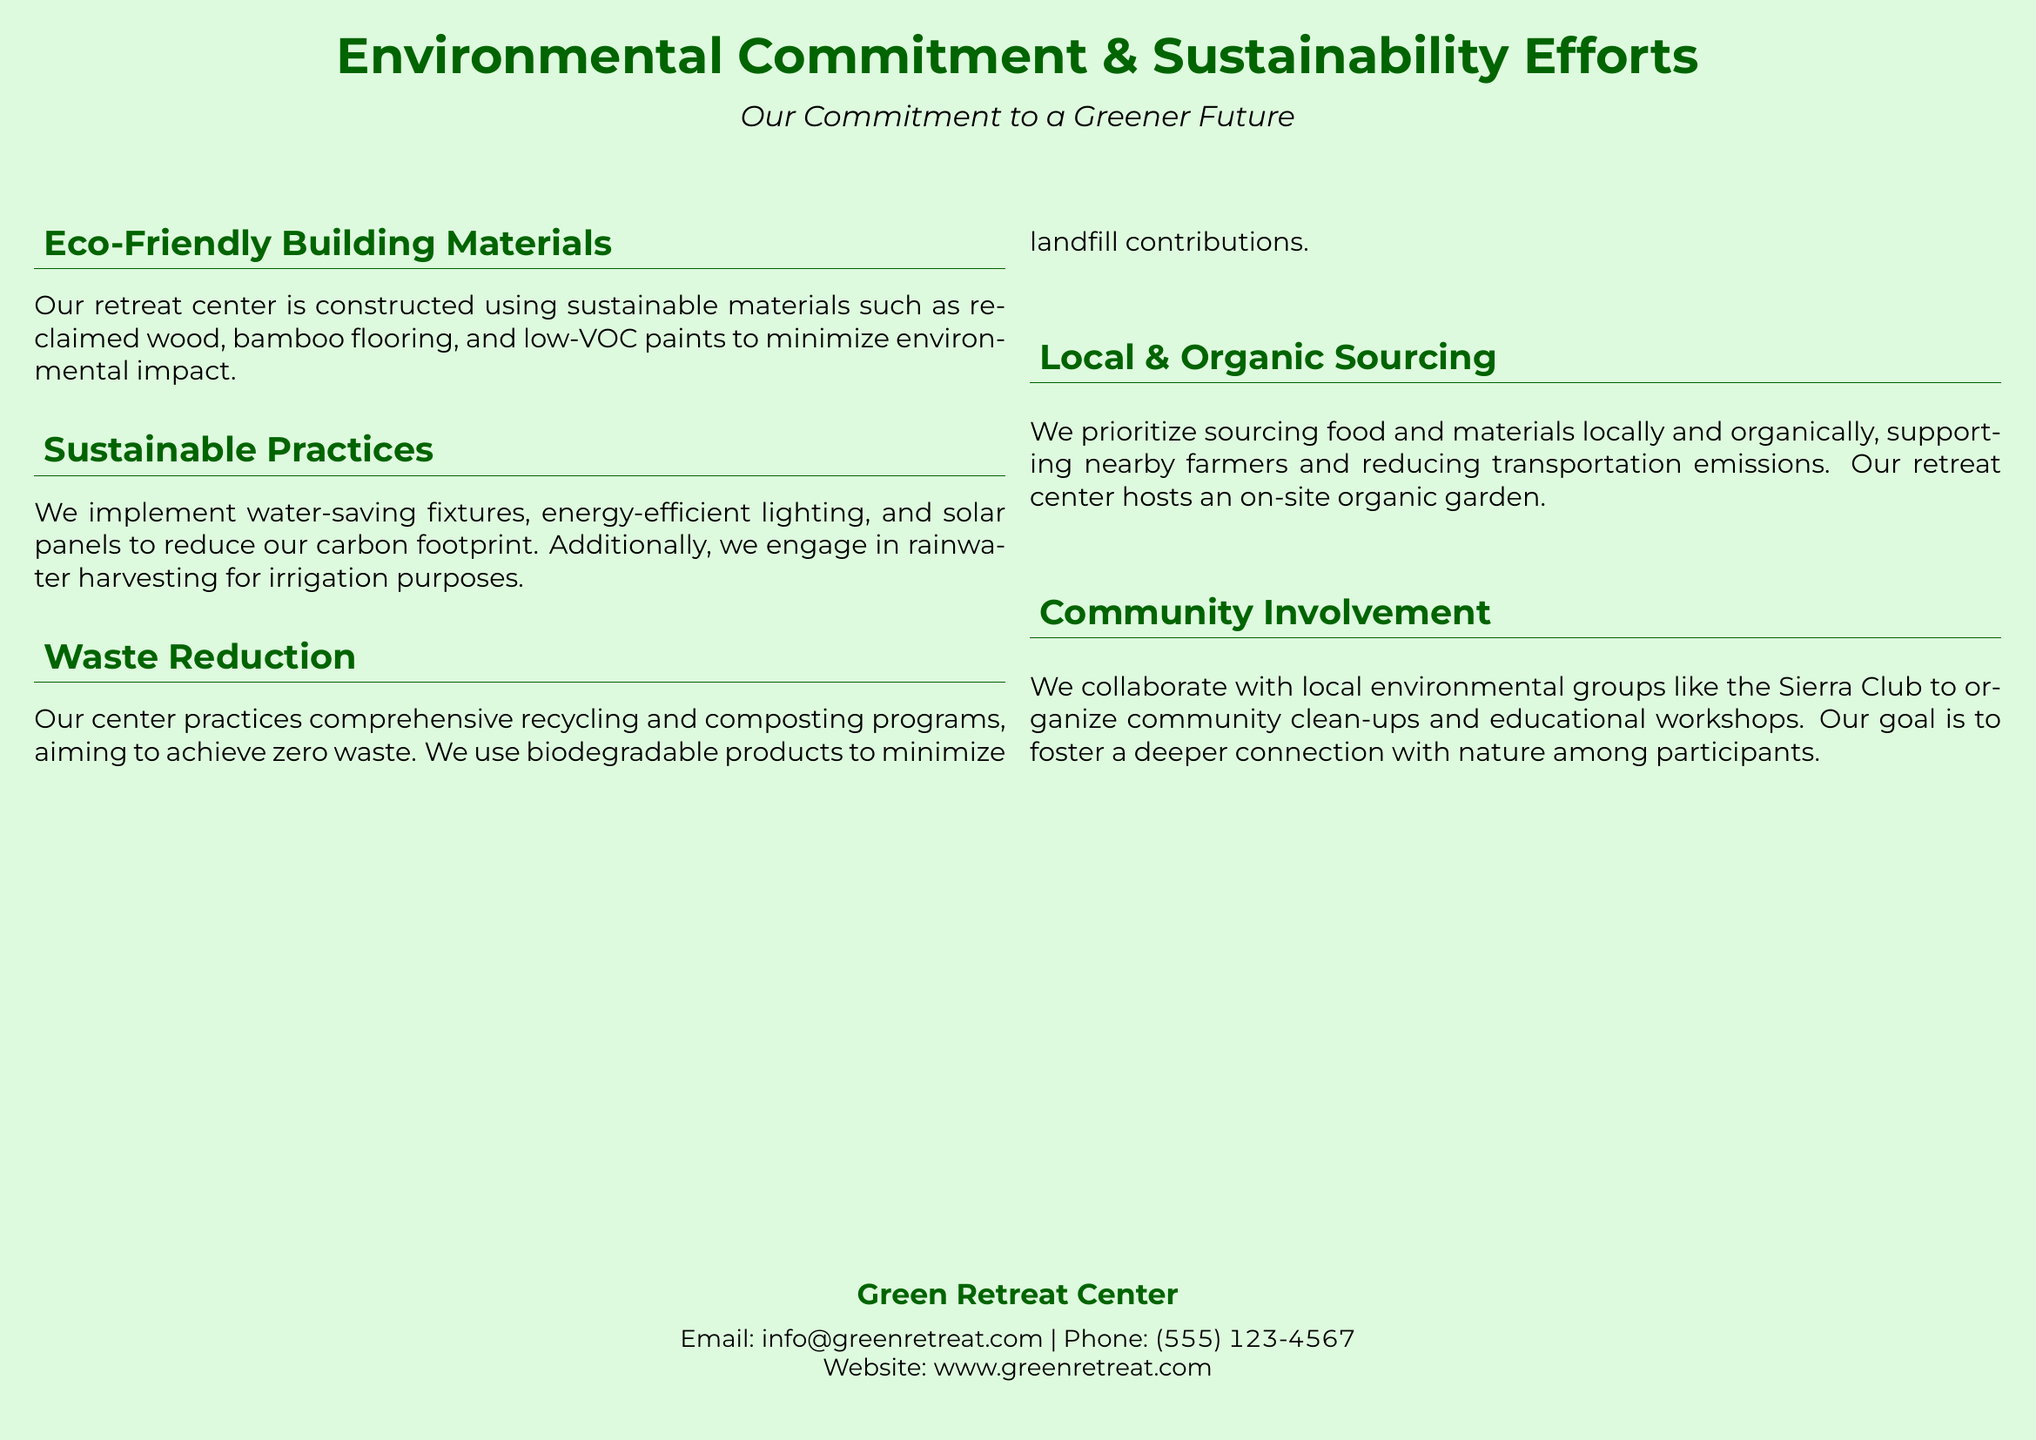What materials are used in construction? The document states that sustainable materials include reclaimed wood, bamboo flooring, and low-VOC paints.
Answer: Reclaimed wood, bamboo flooring, low-VOC paints What water-saving fixtures does the center implement? The text mentions water-saving fixtures as part of the sustainable practices at the center.
Answer: Water-saving fixtures What is the goal of the waste reduction program? The document indicates the aim is to achieve zero waste through comprehensive recycling and composting.
Answer: Zero waste What type of garden does the retreat center have? The information shows that the center hosts an on-site organic garden, highlighting local and organic sourcing.
Answer: On-site organic garden Which organization collaborates with the retreat center for community involvement? The document specifies that the center collaborates with the Sierra Club for community clean-ups and workshops.
Answer: Sierra Club What is the email address provided for contact? The document lists the email contact for the Green Retreat Center.
Answer: info@greenretreat.com How many sustainable practices are mentioned in the document? The text outlines four distinct sustainable practices implemented by the center.
Answer: Four What icon represents eco-friendly building materials? The eco-friendly building materials section is marked with a leaf icon according to the document.
Answer: Leaf icon What is the phone number for the retreat center? The document provides a specific phone contact number for the retreat center.
Answer: (555) 123-4567 